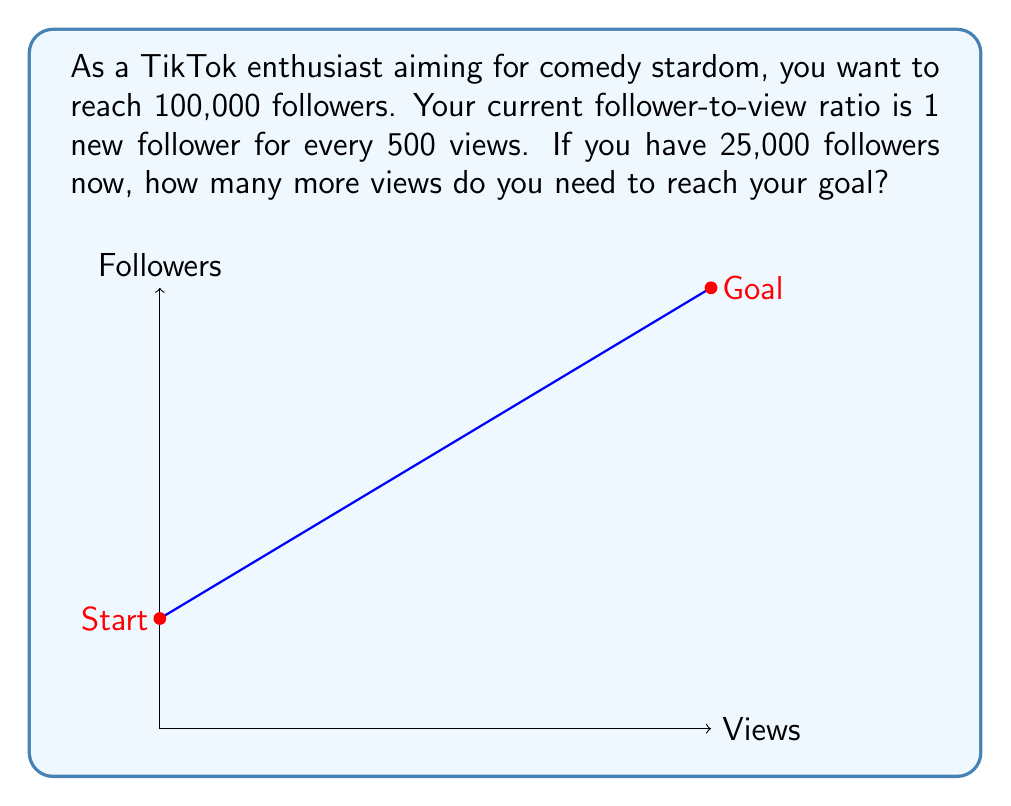Show me your answer to this math problem. Let's approach this step-by-step:

1) First, let's define our variables:
   $x$ = number of additional views needed
   $y$ = number of new followers gained

2) We know that for every 500 views, we gain 1 new follower. This can be expressed as:
   $y = \frac{x}{500}$

3) We need to find how many new followers we need to reach our goal:
   Goal - Current followers = New followers needed
   $100,000 - 25,000 = 75,000$

4) Now we can set up our equation:
   $\frac{x}{500} = 75,000$

5) Solve for $x$:
   $x = 75,000 * 500 = 37,500,000$

Therefore, you need 37,500,000 more views to reach your goal of 100,000 followers.
Answer: 37,500,000 views 